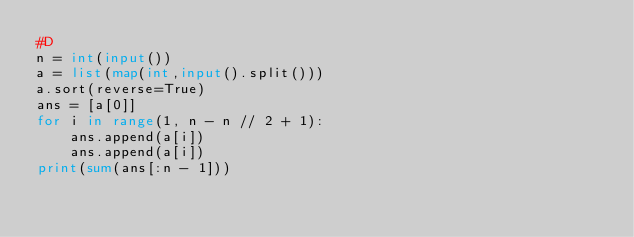<code> <loc_0><loc_0><loc_500><loc_500><_Python_>#D
n = int(input())
a = list(map(int,input().split()))
a.sort(reverse=True)
ans = [a[0]]
for i in range(1, n - n // 2 + 1):
    ans.append(a[i])
    ans.append(a[i])
print(sum(ans[:n - 1]))</code> 